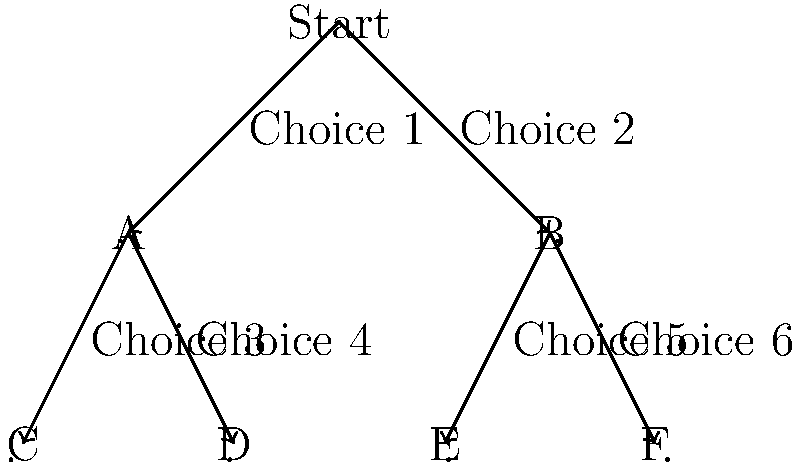In the tree diagram representing branching storylines in a choice-based game, how many unique paths are there from the start to the end of the game? To determine the number of unique paths from start to end in this choice-based game, we need to follow these steps:

1. Identify the starting point: There is one starting point labeled "Start".

2. Analyze the first choice:
   - Choice 1 leads to node A
   - Choice 2 leads to node B

3. Analyze the second set of choices:
   - From node A:
     * Choice 3 leads to node C
     * Choice 4 leads to node D
   - From node B:
     * Choice 5 leads to node E
     * Choice 6 leads to node F

4. Count the number of end nodes:
   There are four end nodes: C, D, E, and F.

5. Trace the paths:
   - Start → Choice 1 → A → Choice 3 → C
   - Start → Choice 1 → A → Choice 4 → D
   - Start → Choice 2 → B → Choice 5 → E
   - Start → Choice 2 → B → Choice 6 → F

Therefore, there are 4 unique paths from the start to the end of the game.
Answer: 4 paths 